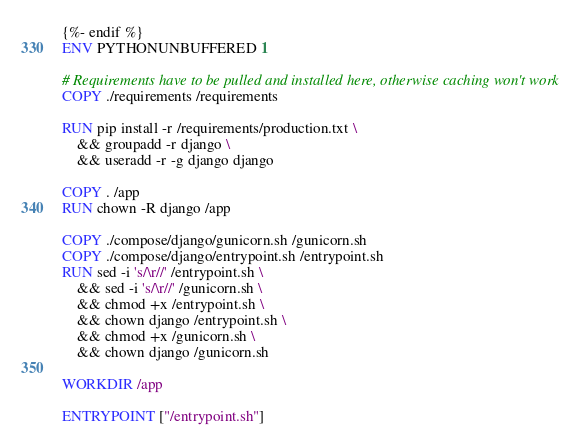<code> <loc_0><loc_0><loc_500><loc_500><_Dockerfile_>{%- endif %}
ENV PYTHONUNBUFFERED 1

# Requirements have to be pulled and installed here, otherwise caching won't work
COPY ./requirements /requirements

RUN pip install -r /requirements/production.txt \
    && groupadd -r django \
    && useradd -r -g django django

COPY . /app
RUN chown -R django /app

COPY ./compose/django/gunicorn.sh /gunicorn.sh
COPY ./compose/django/entrypoint.sh /entrypoint.sh
RUN sed -i 's/\r//' /entrypoint.sh \
    && sed -i 's/\r//' /gunicorn.sh \
    && chmod +x /entrypoint.sh \
    && chown django /entrypoint.sh \
    && chmod +x /gunicorn.sh \
    && chown django /gunicorn.sh

WORKDIR /app

ENTRYPOINT ["/entrypoint.sh"]
</code> 